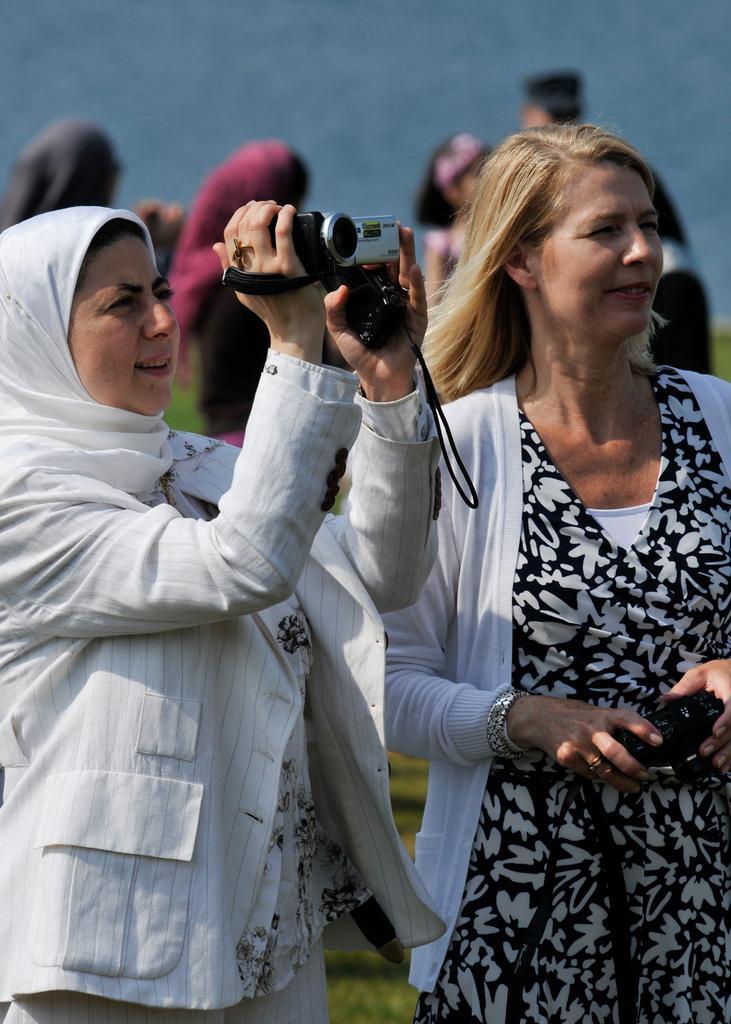In one or two sentences, can you explain what this image depicts? On the left a woman is recording video. On the right a woman is holding camera in her hands. In the background there are few people. 